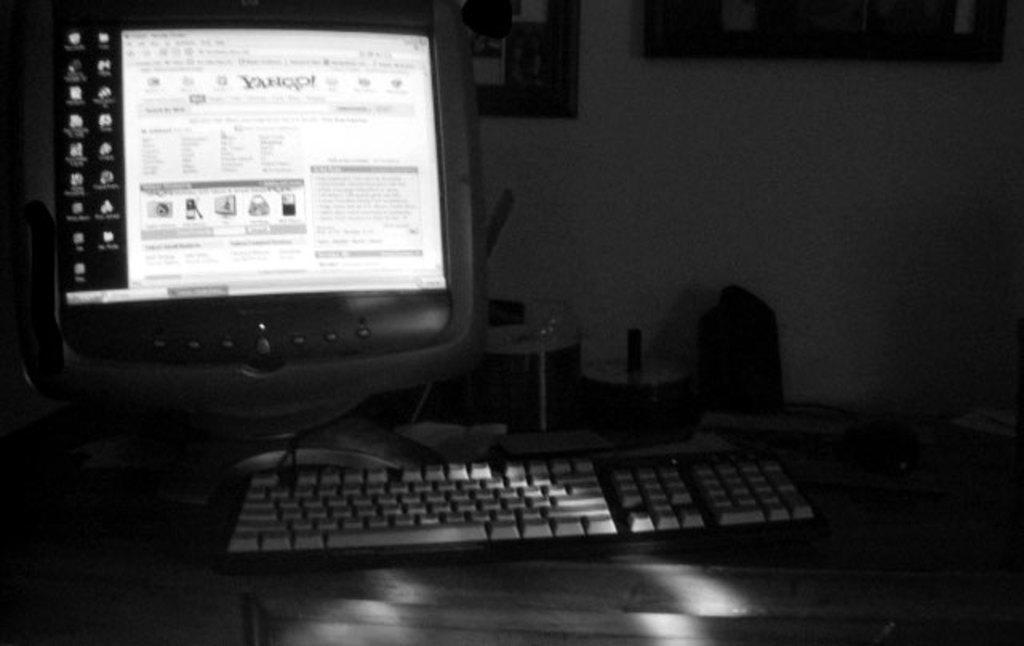Provide a one-sentence caption for the provided image. a computer with the screen turned on to the yahoo web page. 